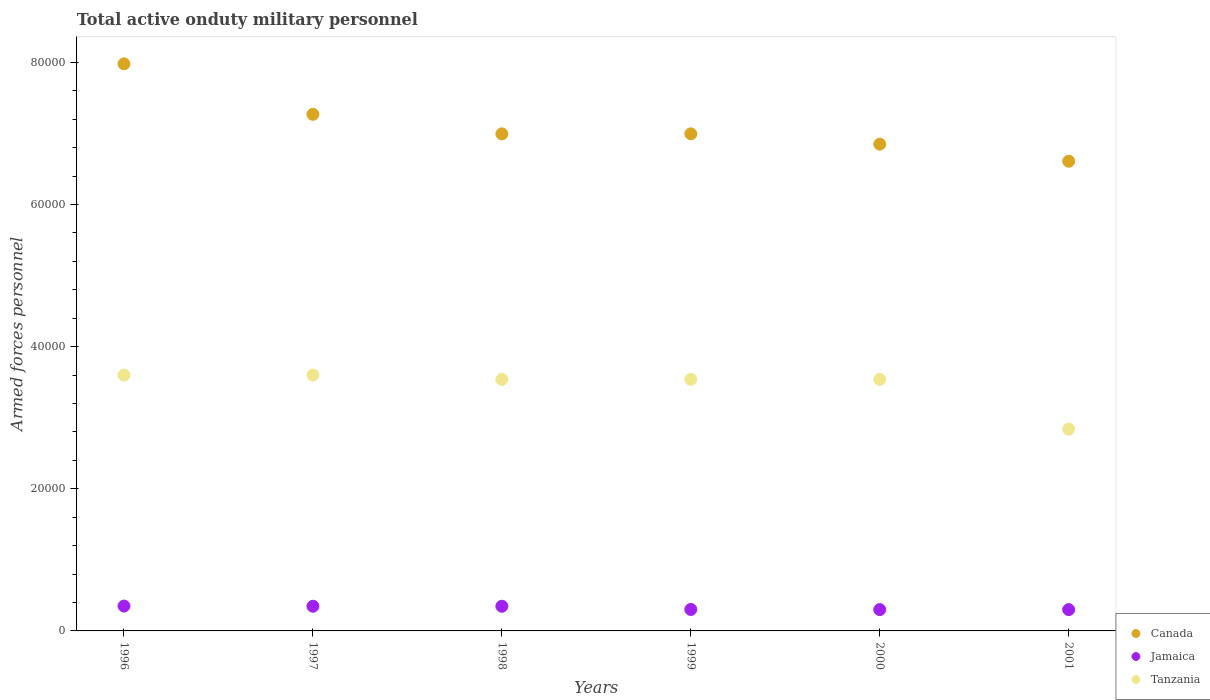What is the number of armed forces personnel in Jamaica in 1999?
Your response must be concise. 3020. Across all years, what is the maximum number of armed forces personnel in Tanzania?
Offer a terse response. 3.60e+04. Across all years, what is the minimum number of armed forces personnel in Tanzania?
Offer a terse response. 2.84e+04. In which year was the number of armed forces personnel in Jamaica minimum?
Your response must be concise. 2000. What is the total number of armed forces personnel in Jamaica in the graph?
Your response must be concise. 1.95e+04. What is the difference between the number of armed forces personnel in Canada in 1997 and that in 2001?
Your answer should be compact. 6600. What is the difference between the number of armed forces personnel in Tanzania in 1997 and the number of armed forces personnel in Canada in 1996?
Ensure brevity in your answer.  -4.38e+04. What is the average number of armed forces personnel in Tanzania per year?
Provide a succinct answer. 3.44e+04. In the year 2000, what is the difference between the number of armed forces personnel in Canada and number of armed forces personnel in Jamaica?
Provide a short and direct response. 6.55e+04. In how many years, is the number of armed forces personnel in Jamaica greater than 56000?
Ensure brevity in your answer.  0. What is the ratio of the number of armed forces personnel in Tanzania in 1998 to that in 2000?
Ensure brevity in your answer.  1. Is the difference between the number of armed forces personnel in Canada in 1996 and 1999 greater than the difference between the number of armed forces personnel in Jamaica in 1996 and 1999?
Provide a succinct answer. Yes. What is the difference between the highest and the lowest number of armed forces personnel in Jamaica?
Offer a terse response. 500. Is it the case that in every year, the sum of the number of armed forces personnel in Jamaica and number of armed forces personnel in Canada  is greater than the number of armed forces personnel in Tanzania?
Provide a short and direct response. Yes. Does the number of armed forces personnel in Jamaica monotonically increase over the years?
Provide a succinct answer. No. How many years are there in the graph?
Your answer should be very brief. 6. What is the difference between two consecutive major ticks on the Y-axis?
Ensure brevity in your answer.  2.00e+04. Are the values on the major ticks of Y-axis written in scientific E-notation?
Offer a terse response. No. How many legend labels are there?
Offer a terse response. 3. What is the title of the graph?
Keep it short and to the point. Total active onduty military personnel. What is the label or title of the Y-axis?
Keep it short and to the point. Armed forces personnel. What is the Armed forces personnel in Canada in 1996?
Offer a terse response. 7.98e+04. What is the Armed forces personnel in Jamaica in 1996?
Your answer should be compact. 3500. What is the Armed forces personnel of Tanzania in 1996?
Provide a succinct answer. 3.60e+04. What is the Armed forces personnel in Canada in 1997?
Ensure brevity in your answer.  7.27e+04. What is the Armed forces personnel in Jamaica in 1997?
Your response must be concise. 3470. What is the Armed forces personnel in Tanzania in 1997?
Offer a very short reply. 3.60e+04. What is the Armed forces personnel in Canada in 1998?
Give a very brief answer. 7.00e+04. What is the Armed forces personnel in Jamaica in 1998?
Make the answer very short. 3470. What is the Armed forces personnel of Tanzania in 1998?
Your answer should be compact. 3.54e+04. What is the Armed forces personnel in Canada in 1999?
Your answer should be very brief. 7.00e+04. What is the Armed forces personnel in Jamaica in 1999?
Provide a succinct answer. 3020. What is the Armed forces personnel of Tanzania in 1999?
Provide a short and direct response. 3.54e+04. What is the Armed forces personnel in Canada in 2000?
Your answer should be very brief. 6.85e+04. What is the Armed forces personnel of Jamaica in 2000?
Provide a short and direct response. 3000. What is the Armed forces personnel of Tanzania in 2000?
Offer a very short reply. 3.54e+04. What is the Armed forces personnel of Canada in 2001?
Your response must be concise. 6.61e+04. What is the Armed forces personnel of Jamaica in 2001?
Offer a terse response. 3000. What is the Armed forces personnel of Tanzania in 2001?
Offer a very short reply. 2.84e+04. Across all years, what is the maximum Armed forces personnel of Canada?
Give a very brief answer. 7.98e+04. Across all years, what is the maximum Armed forces personnel in Jamaica?
Provide a succinct answer. 3500. Across all years, what is the maximum Armed forces personnel in Tanzania?
Keep it short and to the point. 3.60e+04. Across all years, what is the minimum Armed forces personnel of Canada?
Make the answer very short. 6.61e+04. Across all years, what is the minimum Armed forces personnel of Jamaica?
Offer a terse response. 3000. Across all years, what is the minimum Armed forces personnel in Tanzania?
Make the answer very short. 2.84e+04. What is the total Armed forces personnel of Canada in the graph?
Your response must be concise. 4.27e+05. What is the total Armed forces personnel of Jamaica in the graph?
Keep it short and to the point. 1.95e+04. What is the total Armed forces personnel in Tanzania in the graph?
Keep it short and to the point. 2.07e+05. What is the difference between the Armed forces personnel of Canada in 1996 and that in 1997?
Provide a short and direct response. 7100. What is the difference between the Armed forces personnel of Jamaica in 1996 and that in 1997?
Provide a succinct answer. 30. What is the difference between the Armed forces personnel in Canada in 1996 and that in 1998?
Provide a short and direct response. 9850. What is the difference between the Armed forces personnel in Tanzania in 1996 and that in 1998?
Provide a succinct answer. 600. What is the difference between the Armed forces personnel of Canada in 1996 and that in 1999?
Your answer should be compact. 9850. What is the difference between the Armed forces personnel of Jamaica in 1996 and that in 1999?
Provide a short and direct response. 480. What is the difference between the Armed forces personnel in Tanzania in 1996 and that in 1999?
Your response must be concise. 600. What is the difference between the Armed forces personnel of Canada in 1996 and that in 2000?
Provide a short and direct response. 1.13e+04. What is the difference between the Armed forces personnel of Jamaica in 1996 and that in 2000?
Your answer should be very brief. 500. What is the difference between the Armed forces personnel in Tanzania in 1996 and that in 2000?
Keep it short and to the point. 600. What is the difference between the Armed forces personnel of Canada in 1996 and that in 2001?
Offer a very short reply. 1.37e+04. What is the difference between the Armed forces personnel in Tanzania in 1996 and that in 2001?
Provide a succinct answer. 7600. What is the difference between the Armed forces personnel in Canada in 1997 and that in 1998?
Keep it short and to the point. 2750. What is the difference between the Armed forces personnel of Jamaica in 1997 and that in 1998?
Offer a very short reply. 0. What is the difference between the Armed forces personnel of Tanzania in 1997 and that in 1998?
Offer a very short reply. 600. What is the difference between the Armed forces personnel of Canada in 1997 and that in 1999?
Your answer should be compact. 2750. What is the difference between the Armed forces personnel of Jamaica in 1997 and that in 1999?
Offer a very short reply. 450. What is the difference between the Armed forces personnel in Tanzania in 1997 and that in 1999?
Keep it short and to the point. 600. What is the difference between the Armed forces personnel of Canada in 1997 and that in 2000?
Provide a succinct answer. 4200. What is the difference between the Armed forces personnel of Jamaica in 1997 and that in 2000?
Ensure brevity in your answer.  470. What is the difference between the Armed forces personnel of Tanzania in 1997 and that in 2000?
Your answer should be compact. 600. What is the difference between the Armed forces personnel in Canada in 1997 and that in 2001?
Make the answer very short. 6600. What is the difference between the Armed forces personnel of Jamaica in 1997 and that in 2001?
Your response must be concise. 470. What is the difference between the Armed forces personnel in Tanzania in 1997 and that in 2001?
Give a very brief answer. 7600. What is the difference between the Armed forces personnel in Canada in 1998 and that in 1999?
Give a very brief answer. 0. What is the difference between the Armed forces personnel of Jamaica in 1998 and that in 1999?
Give a very brief answer. 450. What is the difference between the Armed forces personnel in Tanzania in 1998 and that in 1999?
Your response must be concise. 0. What is the difference between the Armed forces personnel of Canada in 1998 and that in 2000?
Your response must be concise. 1450. What is the difference between the Armed forces personnel in Jamaica in 1998 and that in 2000?
Offer a very short reply. 470. What is the difference between the Armed forces personnel of Canada in 1998 and that in 2001?
Make the answer very short. 3850. What is the difference between the Armed forces personnel in Jamaica in 1998 and that in 2001?
Your answer should be compact. 470. What is the difference between the Armed forces personnel in Tanzania in 1998 and that in 2001?
Your answer should be very brief. 7000. What is the difference between the Armed forces personnel in Canada in 1999 and that in 2000?
Offer a very short reply. 1450. What is the difference between the Armed forces personnel in Tanzania in 1999 and that in 2000?
Offer a very short reply. 0. What is the difference between the Armed forces personnel of Canada in 1999 and that in 2001?
Give a very brief answer. 3850. What is the difference between the Armed forces personnel in Jamaica in 1999 and that in 2001?
Provide a succinct answer. 20. What is the difference between the Armed forces personnel of Tanzania in 1999 and that in 2001?
Provide a succinct answer. 7000. What is the difference between the Armed forces personnel in Canada in 2000 and that in 2001?
Your answer should be very brief. 2400. What is the difference between the Armed forces personnel of Tanzania in 2000 and that in 2001?
Your answer should be compact. 7000. What is the difference between the Armed forces personnel in Canada in 1996 and the Armed forces personnel in Jamaica in 1997?
Provide a short and direct response. 7.63e+04. What is the difference between the Armed forces personnel of Canada in 1996 and the Armed forces personnel of Tanzania in 1997?
Ensure brevity in your answer.  4.38e+04. What is the difference between the Armed forces personnel of Jamaica in 1996 and the Armed forces personnel of Tanzania in 1997?
Provide a succinct answer. -3.25e+04. What is the difference between the Armed forces personnel of Canada in 1996 and the Armed forces personnel of Jamaica in 1998?
Your answer should be very brief. 7.63e+04. What is the difference between the Armed forces personnel of Canada in 1996 and the Armed forces personnel of Tanzania in 1998?
Your response must be concise. 4.44e+04. What is the difference between the Armed forces personnel in Jamaica in 1996 and the Armed forces personnel in Tanzania in 1998?
Give a very brief answer. -3.19e+04. What is the difference between the Armed forces personnel in Canada in 1996 and the Armed forces personnel in Jamaica in 1999?
Give a very brief answer. 7.68e+04. What is the difference between the Armed forces personnel of Canada in 1996 and the Armed forces personnel of Tanzania in 1999?
Provide a succinct answer. 4.44e+04. What is the difference between the Armed forces personnel of Jamaica in 1996 and the Armed forces personnel of Tanzania in 1999?
Give a very brief answer. -3.19e+04. What is the difference between the Armed forces personnel of Canada in 1996 and the Armed forces personnel of Jamaica in 2000?
Your answer should be compact. 7.68e+04. What is the difference between the Armed forces personnel in Canada in 1996 and the Armed forces personnel in Tanzania in 2000?
Provide a succinct answer. 4.44e+04. What is the difference between the Armed forces personnel in Jamaica in 1996 and the Armed forces personnel in Tanzania in 2000?
Ensure brevity in your answer.  -3.19e+04. What is the difference between the Armed forces personnel in Canada in 1996 and the Armed forces personnel in Jamaica in 2001?
Provide a succinct answer. 7.68e+04. What is the difference between the Armed forces personnel in Canada in 1996 and the Armed forces personnel in Tanzania in 2001?
Give a very brief answer. 5.14e+04. What is the difference between the Armed forces personnel of Jamaica in 1996 and the Armed forces personnel of Tanzania in 2001?
Keep it short and to the point. -2.49e+04. What is the difference between the Armed forces personnel in Canada in 1997 and the Armed forces personnel in Jamaica in 1998?
Make the answer very short. 6.92e+04. What is the difference between the Armed forces personnel in Canada in 1997 and the Armed forces personnel in Tanzania in 1998?
Offer a very short reply. 3.73e+04. What is the difference between the Armed forces personnel of Jamaica in 1997 and the Armed forces personnel of Tanzania in 1998?
Offer a terse response. -3.19e+04. What is the difference between the Armed forces personnel of Canada in 1997 and the Armed forces personnel of Jamaica in 1999?
Keep it short and to the point. 6.97e+04. What is the difference between the Armed forces personnel in Canada in 1997 and the Armed forces personnel in Tanzania in 1999?
Keep it short and to the point. 3.73e+04. What is the difference between the Armed forces personnel of Jamaica in 1997 and the Armed forces personnel of Tanzania in 1999?
Offer a very short reply. -3.19e+04. What is the difference between the Armed forces personnel in Canada in 1997 and the Armed forces personnel in Jamaica in 2000?
Provide a short and direct response. 6.97e+04. What is the difference between the Armed forces personnel in Canada in 1997 and the Armed forces personnel in Tanzania in 2000?
Your response must be concise. 3.73e+04. What is the difference between the Armed forces personnel in Jamaica in 1997 and the Armed forces personnel in Tanzania in 2000?
Provide a succinct answer. -3.19e+04. What is the difference between the Armed forces personnel in Canada in 1997 and the Armed forces personnel in Jamaica in 2001?
Offer a terse response. 6.97e+04. What is the difference between the Armed forces personnel of Canada in 1997 and the Armed forces personnel of Tanzania in 2001?
Your answer should be compact. 4.43e+04. What is the difference between the Armed forces personnel of Jamaica in 1997 and the Armed forces personnel of Tanzania in 2001?
Keep it short and to the point. -2.49e+04. What is the difference between the Armed forces personnel in Canada in 1998 and the Armed forces personnel in Jamaica in 1999?
Your response must be concise. 6.69e+04. What is the difference between the Armed forces personnel of Canada in 1998 and the Armed forces personnel of Tanzania in 1999?
Give a very brief answer. 3.46e+04. What is the difference between the Armed forces personnel of Jamaica in 1998 and the Armed forces personnel of Tanzania in 1999?
Offer a terse response. -3.19e+04. What is the difference between the Armed forces personnel in Canada in 1998 and the Armed forces personnel in Jamaica in 2000?
Provide a succinct answer. 6.70e+04. What is the difference between the Armed forces personnel of Canada in 1998 and the Armed forces personnel of Tanzania in 2000?
Offer a terse response. 3.46e+04. What is the difference between the Armed forces personnel in Jamaica in 1998 and the Armed forces personnel in Tanzania in 2000?
Give a very brief answer. -3.19e+04. What is the difference between the Armed forces personnel in Canada in 1998 and the Armed forces personnel in Jamaica in 2001?
Provide a succinct answer. 6.70e+04. What is the difference between the Armed forces personnel of Canada in 1998 and the Armed forces personnel of Tanzania in 2001?
Your answer should be very brief. 4.16e+04. What is the difference between the Armed forces personnel in Jamaica in 1998 and the Armed forces personnel in Tanzania in 2001?
Provide a succinct answer. -2.49e+04. What is the difference between the Armed forces personnel in Canada in 1999 and the Armed forces personnel in Jamaica in 2000?
Your response must be concise. 6.70e+04. What is the difference between the Armed forces personnel of Canada in 1999 and the Armed forces personnel of Tanzania in 2000?
Your response must be concise. 3.46e+04. What is the difference between the Armed forces personnel in Jamaica in 1999 and the Armed forces personnel in Tanzania in 2000?
Your response must be concise. -3.24e+04. What is the difference between the Armed forces personnel in Canada in 1999 and the Armed forces personnel in Jamaica in 2001?
Ensure brevity in your answer.  6.70e+04. What is the difference between the Armed forces personnel of Canada in 1999 and the Armed forces personnel of Tanzania in 2001?
Give a very brief answer. 4.16e+04. What is the difference between the Armed forces personnel in Jamaica in 1999 and the Armed forces personnel in Tanzania in 2001?
Provide a succinct answer. -2.54e+04. What is the difference between the Armed forces personnel in Canada in 2000 and the Armed forces personnel in Jamaica in 2001?
Provide a succinct answer. 6.55e+04. What is the difference between the Armed forces personnel of Canada in 2000 and the Armed forces personnel of Tanzania in 2001?
Provide a short and direct response. 4.01e+04. What is the difference between the Armed forces personnel of Jamaica in 2000 and the Armed forces personnel of Tanzania in 2001?
Provide a succinct answer. -2.54e+04. What is the average Armed forces personnel in Canada per year?
Your response must be concise. 7.12e+04. What is the average Armed forces personnel of Jamaica per year?
Provide a short and direct response. 3243.33. What is the average Armed forces personnel in Tanzania per year?
Your answer should be very brief. 3.44e+04. In the year 1996, what is the difference between the Armed forces personnel in Canada and Armed forces personnel in Jamaica?
Keep it short and to the point. 7.63e+04. In the year 1996, what is the difference between the Armed forces personnel of Canada and Armed forces personnel of Tanzania?
Provide a succinct answer. 4.38e+04. In the year 1996, what is the difference between the Armed forces personnel of Jamaica and Armed forces personnel of Tanzania?
Give a very brief answer. -3.25e+04. In the year 1997, what is the difference between the Armed forces personnel of Canada and Armed forces personnel of Jamaica?
Ensure brevity in your answer.  6.92e+04. In the year 1997, what is the difference between the Armed forces personnel of Canada and Armed forces personnel of Tanzania?
Keep it short and to the point. 3.67e+04. In the year 1997, what is the difference between the Armed forces personnel in Jamaica and Armed forces personnel in Tanzania?
Make the answer very short. -3.25e+04. In the year 1998, what is the difference between the Armed forces personnel of Canada and Armed forces personnel of Jamaica?
Offer a very short reply. 6.65e+04. In the year 1998, what is the difference between the Armed forces personnel in Canada and Armed forces personnel in Tanzania?
Offer a terse response. 3.46e+04. In the year 1998, what is the difference between the Armed forces personnel of Jamaica and Armed forces personnel of Tanzania?
Keep it short and to the point. -3.19e+04. In the year 1999, what is the difference between the Armed forces personnel of Canada and Armed forces personnel of Jamaica?
Make the answer very short. 6.69e+04. In the year 1999, what is the difference between the Armed forces personnel of Canada and Armed forces personnel of Tanzania?
Provide a succinct answer. 3.46e+04. In the year 1999, what is the difference between the Armed forces personnel of Jamaica and Armed forces personnel of Tanzania?
Provide a succinct answer. -3.24e+04. In the year 2000, what is the difference between the Armed forces personnel in Canada and Armed forces personnel in Jamaica?
Make the answer very short. 6.55e+04. In the year 2000, what is the difference between the Armed forces personnel of Canada and Armed forces personnel of Tanzania?
Your answer should be very brief. 3.31e+04. In the year 2000, what is the difference between the Armed forces personnel in Jamaica and Armed forces personnel in Tanzania?
Your answer should be very brief. -3.24e+04. In the year 2001, what is the difference between the Armed forces personnel of Canada and Armed forces personnel of Jamaica?
Ensure brevity in your answer.  6.31e+04. In the year 2001, what is the difference between the Armed forces personnel in Canada and Armed forces personnel in Tanzania?
Make the answer very short. 3.77e+04. In the year 2001, what is the difference between the Armed forces personnel in Jamaica and Armed forces personnel in Tanzania?
Provide a succinct answer. -2.54e+04. What is the ratio of the Armed forces personnel of Canada in 1996 to that in 1997?
Your response must be concise. 1.1. What is the ratio of the Armed forces personnel in Jamaica in 1996 to that in 1997?
Provide a succinct answer. 1.01. What is the ratio of the Armed forces personnel in Canada in 1996 to that in 1998?
Ensure brevity in your answer.  1.14. What is the ratio of the Armed forces personnel in Jamaica in 1996 to that in 1998?
Provide a short and direct response. 1.01. What is the ratio of the Armed forces personnel in Tanzania in 1996 to that in 1998?
Offer a very short reply. 1.02. What is the ratio of the Armed forces personnel of Canada in 1996 to that in 1999?
Your response must be concise. 1.14. What is the ratio of the Armed forces personnel in Jamaica in 1996 to that in 1999?
Your response must be concise. 1.16. What is the ratio of the Armed forces personnel in Tanzania in 1996 to that in 1999?
Make the answer very short. 1.02. What is the ratio of the Armed forces personnel in Canada in 1996 to that in 2000?
Your answer should be very brief. 1.17. What is the ratio of the Armed forces personnel in Tanzania in 1996 to that in 2000?
Offer a terse response. 1.02. What is the ratio of the Armed forces personnel in Canada in 1996 to that in 2001?
Make the answer very short. 1.21. What is the ratio of the Armed forces personnel in Jamaica in 1996 to that in 2001?
Provide a succinct answer. 1.17. What is the ratio of the Armed forces personnel in Tanzania in 1996 to that in 2001?
Offer a very short reply. 1.27. What is the ratio of the Armed forces personnel in Canada in 1997 to that in 1998?
Offer a terse response. 1.04. What is the ratio of the Armed forces personnel of Jamaica in 1997 to that in 1998?
Offer a very short reply. 1. What is the ratio of the Armed forces personnel in Tanzania in 1997 to that in 1998?
Give a very brief answer. 1.02. What is the ratio of the Armed forces personnel of Canada in 1997 to that in 1999?
Offer a terse response. 1.04. What is the ratio of the Armed forces personnel of Jamaica in 1997 to that in 1999?
Ensure brevity in your answer.  1.15. What is the ratio of the Armed forces personnel of Tanzania in 1997 to that in 1999?
Offer a terse response. 1.02. What is the ratio of the Armed forces personnel in Canada in 1997 to that in 2000?
Keep it short and to the point. 1.06. What is the ratio of the Armed forces personnel in Jamaica in 1997 to that in 2000?
Make the answer very short. 1.16. What is the ratio of the Armed forces personnel of Tanzania in 1997 to that in 2000?
Provide a short and direct response. 1.02. What is the ratio of the Armed forces personnel in Canada in 1997 to that in 2001?
Keep it short and to the point. 1.1. What is the ratio of the Armed forces personnel of Jamaica in 1997 to that in 2001?
Give a very brief answer. 1.16. What is the ratio of the Armed forces personnel in Tanzania in 1997 to that in 2001?
Give a very brief answer. 1.27. What is the ratio of the Armed forces personnel of Jamaica in 1998 to that in 1999?
Offer a terse response. 1.15. What is the ratio of the Armed forces personnel in Canada in 1998 to that in 2000?
Make the answer very short. 1.02. What is the ratio of the Armed forces personnel of Jamaica in 1998 to that in 2000?
Keep it short and to the point. 1.16. What is the ratio of the Armed forces personnel of Canada in 1998 to that in 2001?
Offer a terse response. 1.06. What is the ratio of the Armed forces personnel of Jamaica in 1998 to that in 2001?
Ensure brevity in your answer.  1.16. What is the ratio of the Armed forces personnel in Tanzania in 1998 to that in 2001?
Your answer should be compact. 1.25. What is the ratio of the Armed forces personnel in Canada in 1999 to that in 2000?
Offer a very short reply. 1.02. What is the ratio of the Armed forces personnel of Jamaica in 1999 to that in 2000?
Offer a terse response. 1.01. What is the ratio of the Armed forces personnel in Canada in 1999 to that in 2001?
Your response must be concise. 1.06. What is the ratio of the Armed forces personnel of Jamaica in 1999 to that in 2001?
Provide a succinct answer. 1.01. What is the ratio of the Armed forces personnel of Tanzania in 1999 to that in 2001?
Your answer should be compact. 1.25. What is the ratio of the Armed forces personnel of Canada in 2000 to that in 2001?
Ensure brevity in your answer.  1.04. What is the ratio of the Armed forces personnel of Tanzania in 2000 to that in 2001?
Your answer should be compact. 1.25. What is the difference between the highest and the second highest Armed forces personnel in Canada?
Keep it short and to the point. 7100. What is the difference between the highest and the second highest Armed forces personnel in Jamaica?
Ensure brevity in your answer.  30. What is the difference between the highest and the lowest Armed forces personnel in Canada?
Give a very brief answer. 1.37e+04. What is the difference between the highest and the lowest Armed forces personnel of Tanzania?
Your answer should be compact. 7600. 